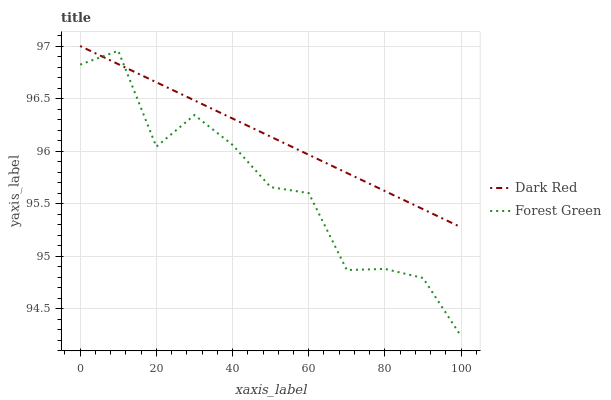Does Forest Green have the minimum area under the curve?
Answer yes or no. Yes. Does Dark Red have the maximum area under the curve?
Answer yes or no. Yes. Does Forest Green have the maximum area under the curve?
Answer yes or no. No. Is Dark Red the smoothest?
Answer yes or no. Yes. Is Forest Green the roughest?
Answer yes or no. Yes. Is Forest Green the smoothest?
Answer yes or no. No. Does Forest Green have the lowest value?
Answer yes or no. Yes. Does Dark Red have the highest value?
Answer yes or no. Yes. Does Forest Green have the highest value?
Answer yes or no. No. Does Dark Red intersect Forest Green?
Answer yes or no. Yes. Is Dark Red less than Forest Green?
Answer yes or no. No. Is Dark Red greater than Forest Green?
Answer yes or no. No. 